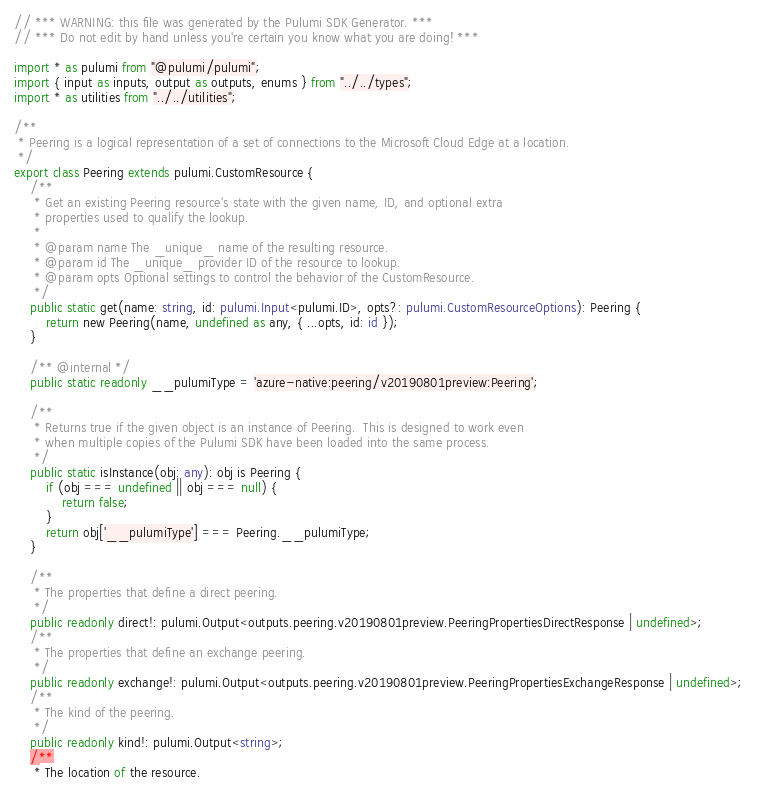Convert code to text. <code><loc_0><loc_0><loc_500><loc_500><_TypeScript_>// *** WARNING: this file was generated by the Pulumi SDK Generator. ***
// *** Do not edit by hand unless you're certain you know what you are doing! ***

import * as pulumi from "@pulumi/pulumi";
import { input as inputs, output as outputs, enums } from "../../types";
import * as utilities from "../../utilities";

/**
 * Peering is a logical representation of a set of connections to the Microsoft Cloud Edge at a location.
 */
export class Peering extends pulumi.CustomResource {
    /**
     * Get an existing Peering resource's state with the given name, ID, and optional extra
     * properties used to qualify the lookup.
     *
     * @param name The _unique_ name of the resulting resource.
     * @param id The _unique_ provider ID of the resource to lookup.
     * @param opts Optional settings to control the behavior of the CustomResource.
     */
    public static get(name: string, id: pulumi.Input<pulumi.ID>, opts?: pulumi.CustomResourceOptions): Peering {
        return new Peering(name, undefined as any, { ...opts, id: id });
    }

    /** @internal */
    public static readonly __pulumiType = 'azure-native:peering/v20190801preview:Peering';

    /**
     * Returns true if the given object is an instance of Peering.  This is designed to work even
     * when multiple copies of the Pulumi SDK have been loaded into the same process.
     */
    public static isInstance(obj: any): obj is Peering {
        if (obj === undefined || obj === null) {
            return false;
        }
        return obj['__pulumiType'] === Peering.__pulumiType;
    }

    /**
     * The properties that define a direct peering.
     */
    public readonly direct!: pulumi.Output<outputs.peering.v20190801preview.PeeringPropertiesDirectResponse | undefined>;
    /**
     * The properties that define an exchange peering.
     */
    public readonly exchange!: pulumi.Output<outputs.peering.v20190801preview.PeeringPropertiesExchangeResponse | undefined>;
    /**
     * The kind of the peering.
     */
    public readonly kind!: pulumi.Output<string>;
    /**
     * The location of the resource.</code> 